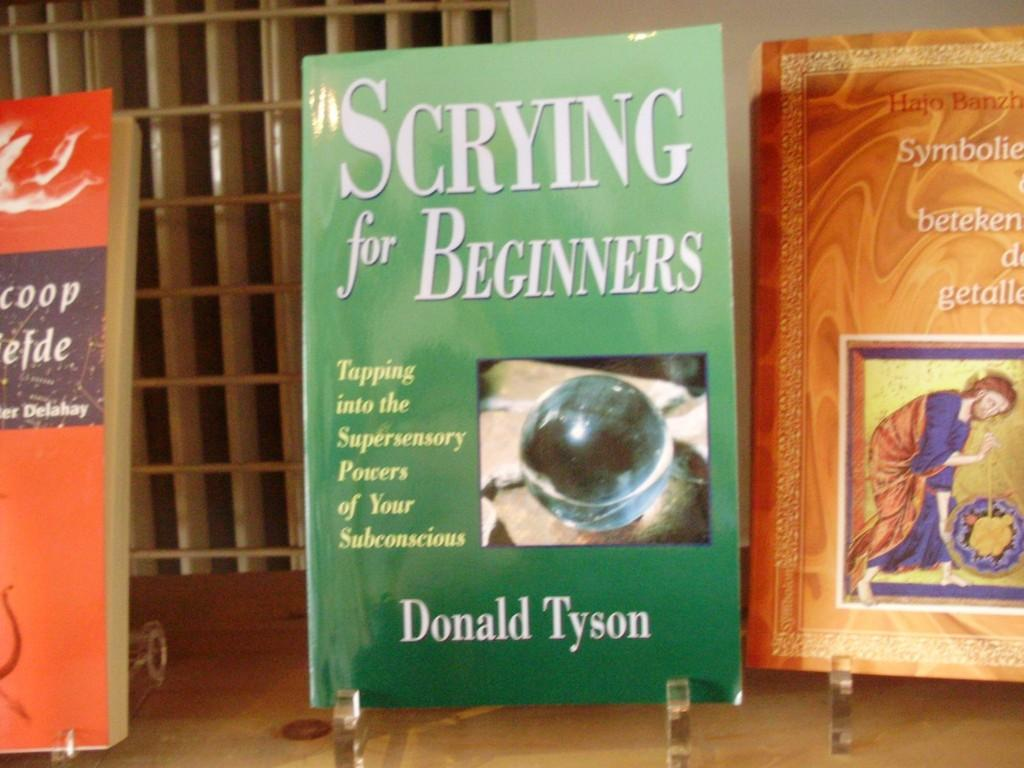<image>
Give a short and clear explanation of the subsequent image. A green book written by Donald Tyson is on display. 